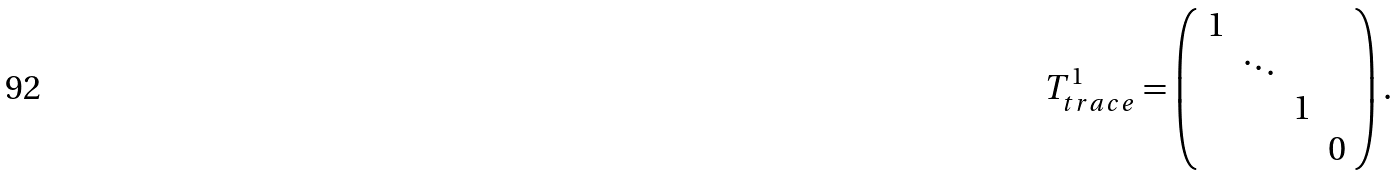Convert formula to latex. <formula><loc_0><loc_0><loc_500><loc_500>T ^ { 1 } _ { t r a c e } = \left ( \begin{array} { c c c c } 1 & & & \\ & \ddots & & \\ & & 1 & \\ & & & 0 \end{array} \right ) .</formula> 